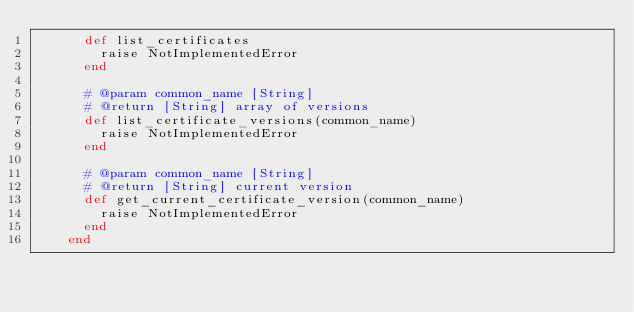Convert code to text. <code><loc_0><loc_0><loc_500><loc_500><_Ruby_>      def list_certificates
        raise NotImplementedError
      end

      # @param common_name [String]
      # @return [String] array of versions
      def list_certificate_versions(common_name)
        raise NotImplementedError
      end

      # @param common_name [String]
      # @return [String] current version
      def get_current_certificate_version(common_name)
        raise NotImplementedError
      end
    end</code> 